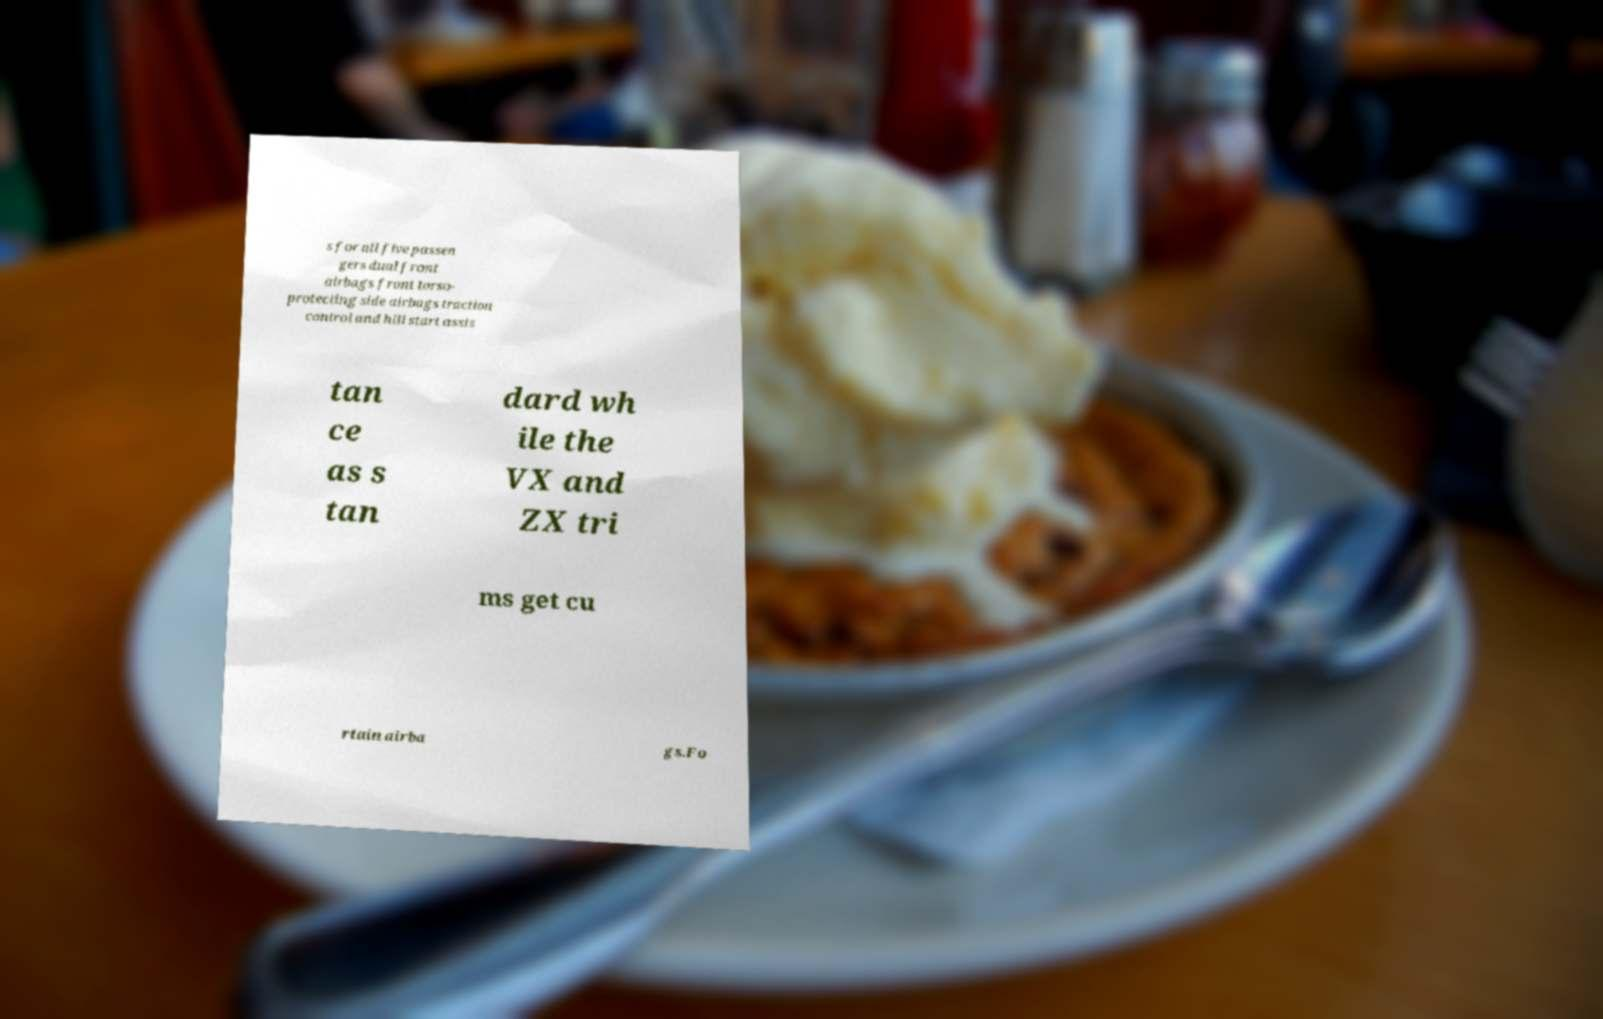Could you extract and type out the text from this image? s for all five passen gers dual front airbags front torso- protecting side airbags traction control and hill start assis tan ce as s tan dard wh ile the VX and ZX tri ms get cu rtain airba gs.Fo 